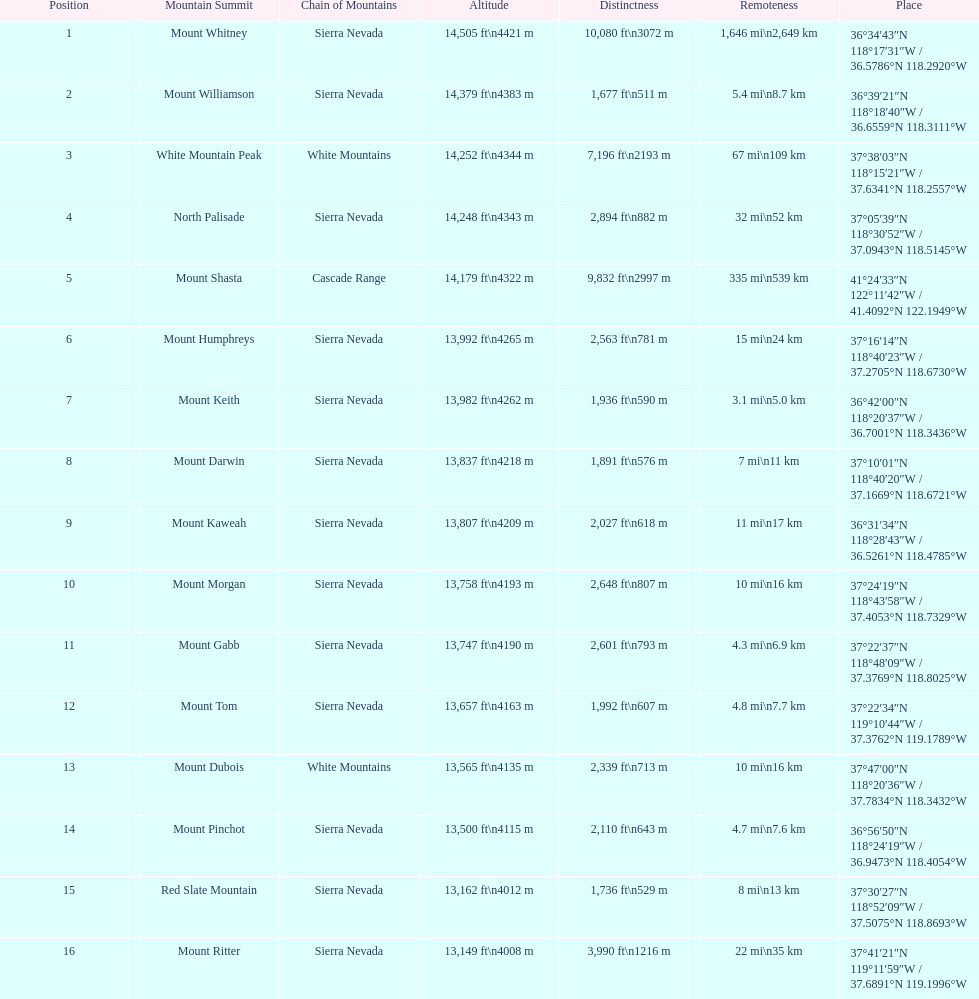What is the tallest peak in the sierra nevadas? Mount Whitney. 